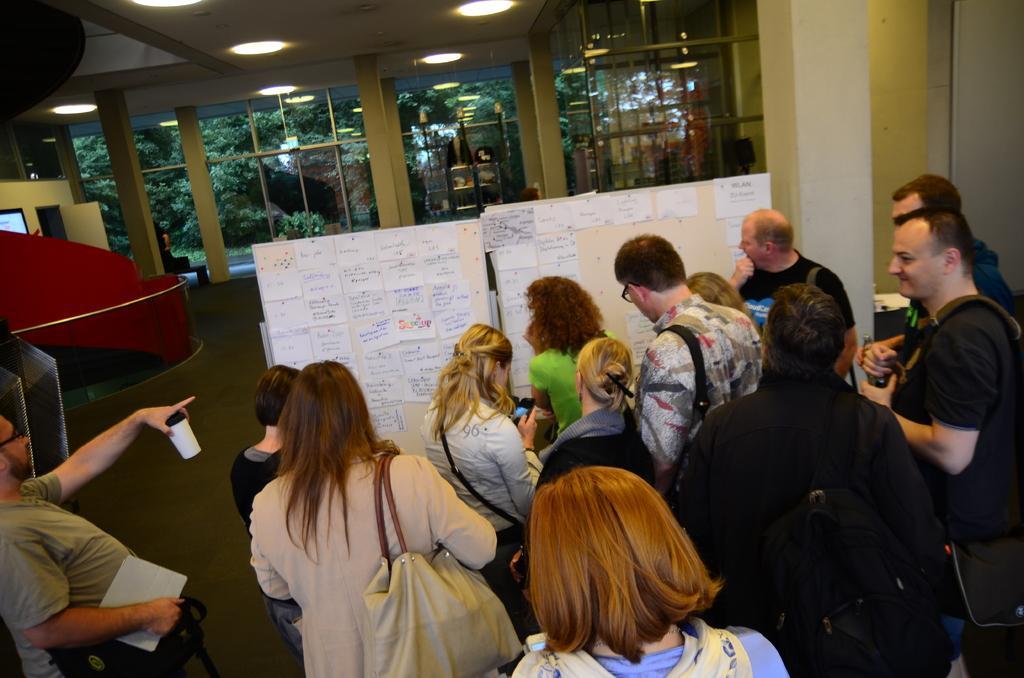How would you summarize this image in a sentence or two? In the picture there are a group of people standing in front of two boards and many papers with some information were attached to that boards and in the background there are windows and doors, behind them there are many trees. 